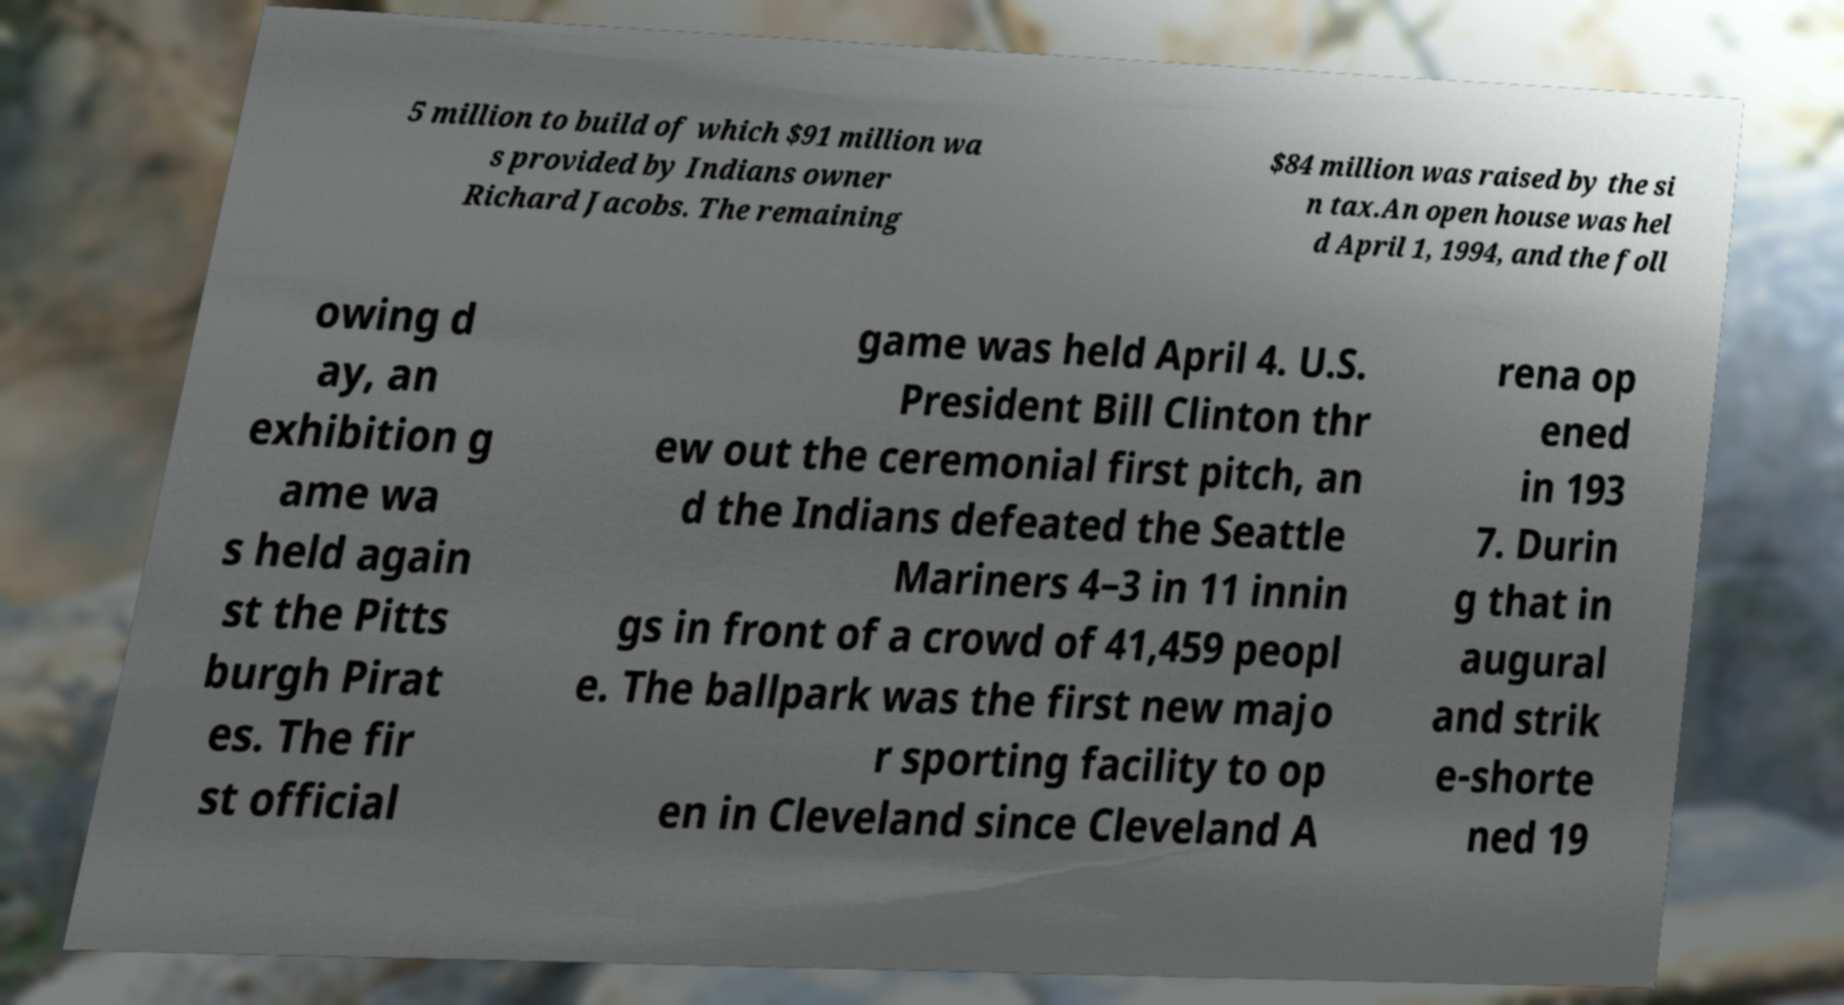What messages or text are displayed in this image? I need them in a readable, typed format. 5 million to build of which $91 million wa s provided by Indians owner Richard Jacobs. The remaining $84 million was raised by the si n tax.An open house was hel d April 1, 1994, and the foll owing d ay, an exhibition g ame wa s held again st the Pitts burgh Pirat es. The fir st official game was held April 4. U.S. President Bill Clinton thr ew out the ceremonial first pitch, an d the Indians defeated the Seattle Mariners 4–3 in 11 innin gs in front of a crowd of 41,459 peopl e. The ballpark was the first new majo r sporting facility to op en in Cleveland since Cleveland A rena op ened in 193 7. Durin g that in augural and strik e-shorte ned 19 